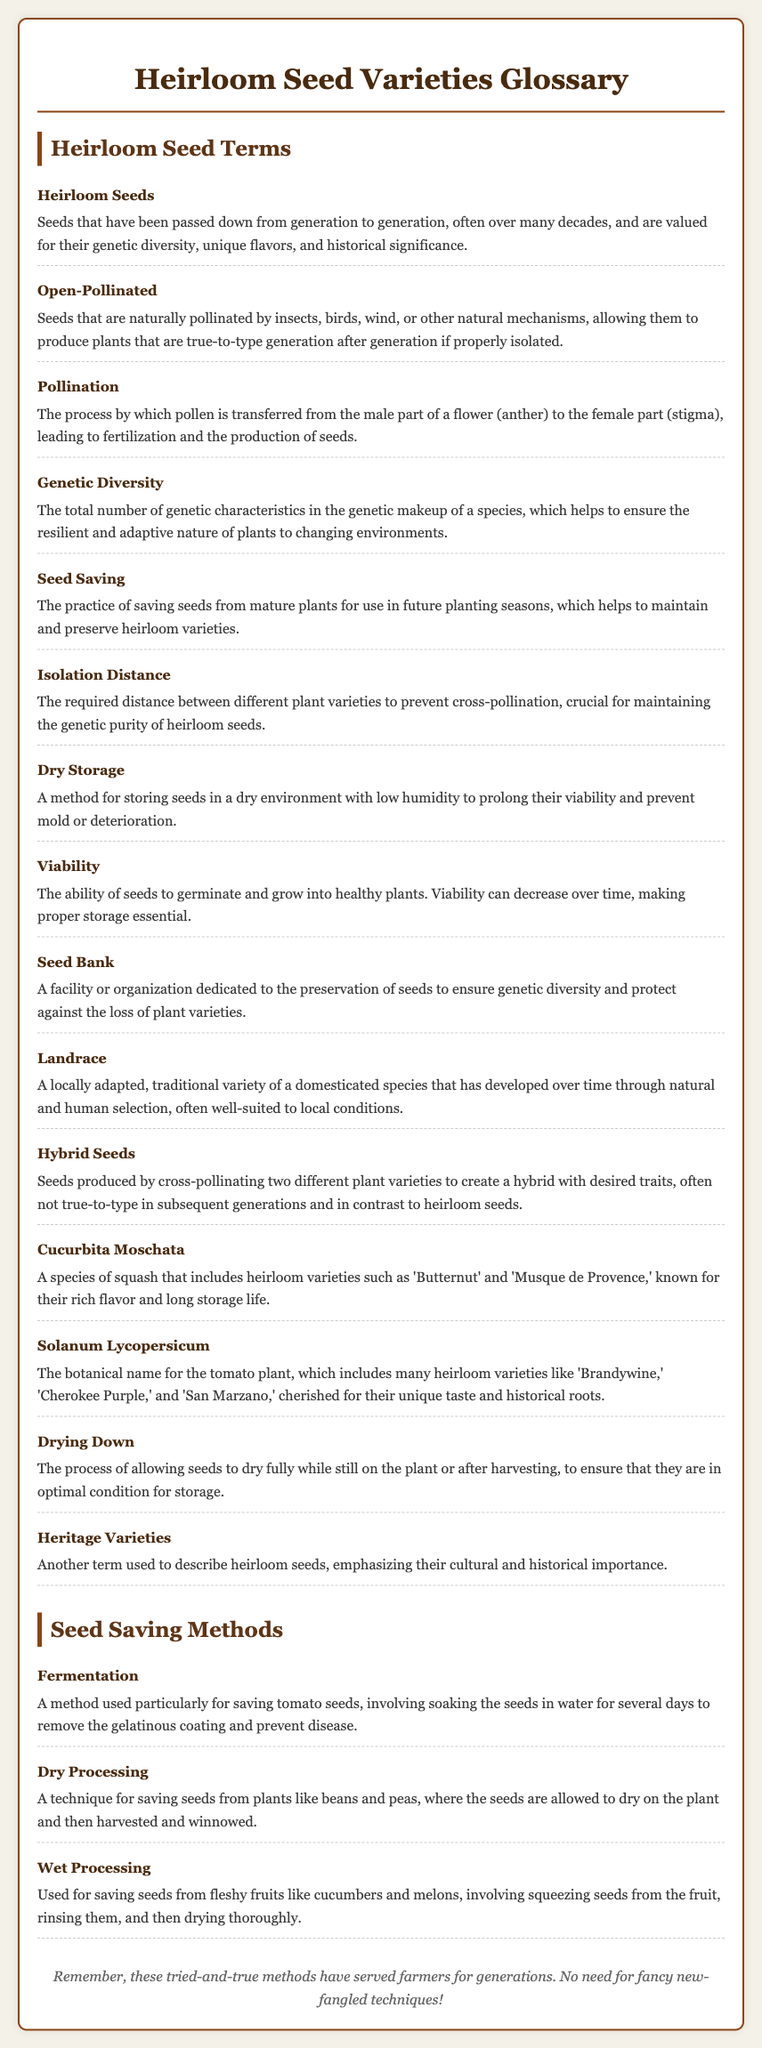What are heirloom seeds? Heirloom seeds are defined in the document as seeds that have been passed down from generation to generation, valued for their genetic diversity, unique flavors, and historical significance.
Answer: Seeds that have been passed down from generation to generation What type of storage prolongs seed viability? The document mentions dry storage as a method for storing seeds to prolong their viability and prevent mold or deterioration.
Answer: Dry storage What are hybrid seeds? The document describes hybrid seeds as seeds produced by cross-pollinating two different plant varieties to create a hybrid with desired traits.
Answer: Seeds produced by cross-pollinating two different plant varieties What is the significance of isolation distance? Isolation distance is crucial for maintaining genetic purity by preventing cross-pollination between different plant varieties.
Answer: Prevent cross-pollination What term describes seeds that can grow into true-to-type plants? The document states that open-pollinated seeds are those that can produce plants that are true-to-type generation after generation if properly isolated.
Answer: Open-pollinated What is a landrace? A landrace is defined in the document as a locally adapted, traditional variety of a domesticated species that has developed over time.
Answer: A locally adapted, traditional variety How are tomato seeds saved using fermentation? The document explains that fermentation is a method involving soaking the seeds in water for several days to remove the gelatinous coating.
Answer: Soaking seeds in water What does "heritage varieties" refer to in the document? The term "heritage varieties" is used as another term to describe heirloom seeds, emphasizing their cultural and historical importance.
Answer: Heirloom seeds How is dry processing used in seed saving? The document describes dry processing as a technique for saving seeds from plants like beans and peas, where they are allowed to dry on the plant.
Answer: A technique for saving seeds from plants like beans and peas 